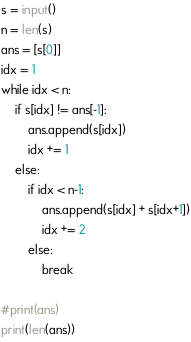<code> <loc_0><loc_0><loc_500><loc_500><_Python_>s = input()
n = len(s)
ans = [s[0]]
idx = 1
while idx < n:
    if s[idx] != ans[-1]:
        ans.append(s[idx])
        idx += 1
    else:
        if idx < n-1:
            ans.append(s[idx] + s[idx+1])
            idx += 2
        else:
            break

#print(ans)
print(len(ans))</code> 